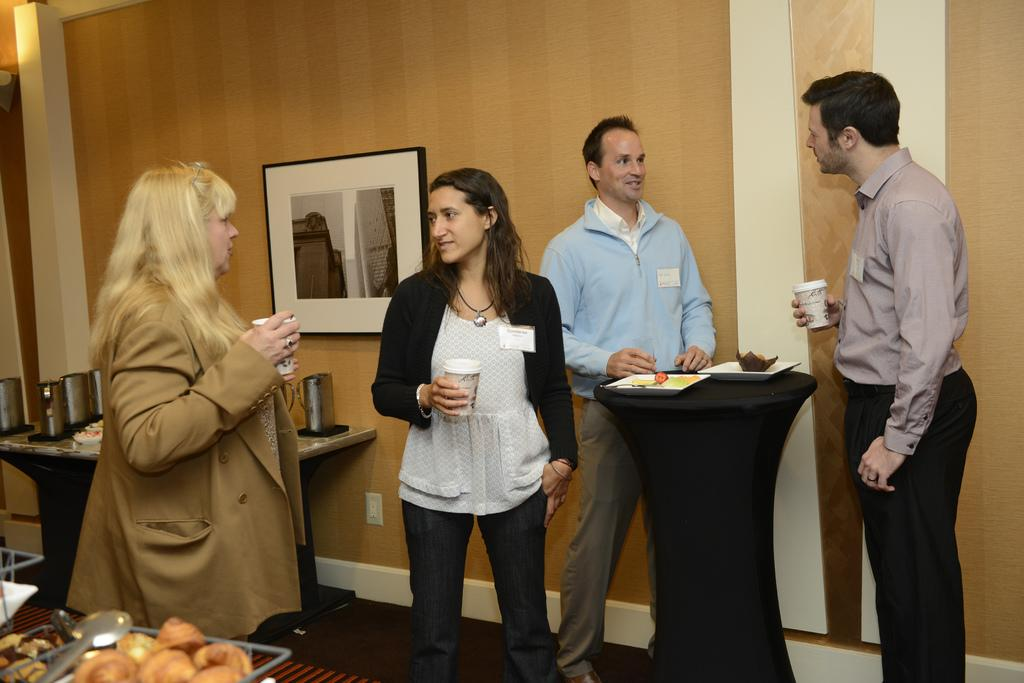How many people are in the image? There are four people in the image, two women and two men. What are the individuals holding in their hands? The individuals are holding cups in their hands. What can be seen in the background of the image? There is a wall in the background of the image, and a photo frame is attached to the wall. What hobbies do the individuals in the image enjoy? The provided facts do not mention any hobbies of the individuals in the image. How do the individuals look in the image? The provided facts do not describe the appearance or expressions of the individuals in the image. 